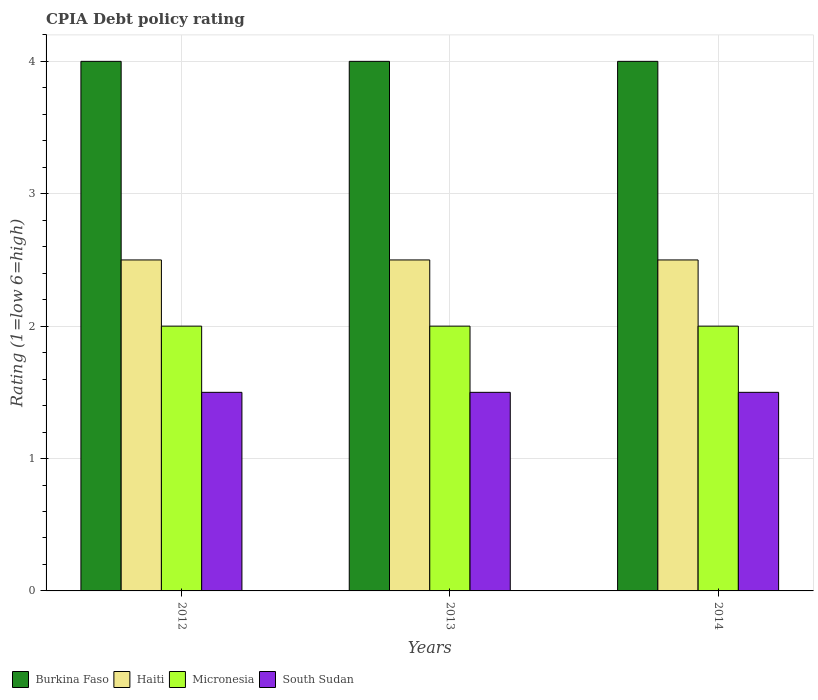How many different coloured bars are there?
Your answer should be compact. 4. How many bars are there on the 3rd tick from the left?
Provide a succinct answer. 4. In how many cases, is the number of bars for a given year not equal to the number of legend labels?
Your answer should be compact. 0. Across all years, what is the maximum CPIA rating in Burkina Faso?
Keep it short and to the point. 4. In how many years, is the CPIA rating in South Sudan greater than 1.4?
Ensure brevity in your answer.  3. Is the CPIA rating in Burkina Faso in 2013 less than that in 2014?
Provide a short and direct response. No. Is the difference between the CPIA rating in Burkina Faso in 2012 and 2014 greater than the difference between the CPIA rating in Micronesia in 2012 and 2014?
Make the answer very short. No. What is the difference between the highest and the lowest CPIA rating in South Sudan?
Offer a very short reply. 0. Is it the case that in every year, the sum of the CPIA rating in South Sudan and CPIA rating in Micronesia is greater than the sum of CPIA rating in Burkina Faso and CPIA rating in Haiti?
Your response must be concise. No. What does the 1st bar from the left in 2014 represents?
Provide a succinct answer. Burkina Faso. What does the 3rd bar from the right in 2012 represents?
Your response must be concise. Haiti. How many years are there in the graph?
Keep it short and to the point. 3. Are the values on the major ticks of Y-axis written in scientific E-notation?
Your answer should be very brief. No. Does the graph contain any zero values?
Make the answer very short. No. Where does the legend appear in the graph?
Give a very brief answer. Bottom left. How many legend labels are there?
Ensure brevity in your answer.  4. What is the title of the graph?
Your answer should be very brief. CPIA Debt policy rating. What is the label or title of the X-axis?
Offer a terse response. Years. What is the Rating (1=low 6=high) of Haiti in 2012?
Provide a succinct answer. 2.5. What is the Rating (1=low 6=high) of South Sudan in 2012?
Give a very brief answer. 1.5. What is the Rating (1=low 6=high) in Burkina Faso in 2013?
Your answer should be very brief. 4. What is the Rating (1=low 6=high) of Haiti in 2013?
Offer a very short reply. 2.5. Across all years, what is the maximum Rating (1=low 6=high) of Haiti?
Ensure brevity in your answer.  2.5. Across all years, what is the maximum Rating (1=low 6=high) in South Sudan?
Your answer should be compact. 1.5. What is the total Rating (1=low 6=high) of Haiti in the graph?
Your answer should be compact. 7.5. What is the total Rating (1=low 6=high) in South Sudan in the graph?
Keep it short and to the point. 4.5. What is the difference between the Rating (1=low 6=high) in Burkina Faso in 2012 and that in 2013?
Your answer should be compact. 0. What is the difference between the Rating (1=low 6=high) of Haiti in 2012 and that in 2013?
Your response must be concise. 0. What is the difference between the Rating (1=low 6=high) in Burkina Faso in 2012 and that in 2014?
Offer a terse response. 0. What is the difference between the Rating (1=low 6=high) in Haiti in 2012 and that in 2014?
Offer a terse response. 0. What is the difference between the Rating (1=low 6=high) of Micronesia in 2012 and that in 2014?
Offer a very short reply. 0. What is the difference between the Rating (1=low 6=high) in South Sudan in 2012 and that in 2014?
Provide a succinct answer. 0. What is the difference between the Rating (1=low 6=high) in Burkina Faso in 2013 and that in 2014?
Your answer should be very brief. 0. What is the difference between the Rating (1=low 6=high) in Burkina Faso in 2012 and the Rating (1=low 6=high) in Micronesia in 2013?
Provide a succinct answer. 2. What is the difference between the Rating (1=low 6=high) of Haiti in 2012 and the Rating (1=low 6=high) of Micronesia in 2013?
Offer a very short reply. 0.5. What is the difference between the Rating (1=low 6=high) of Haiti in 2012 and the Rating (1=low 6=high) of South Sudan in 2013?
Offer a very short reply. 1. What is the difference between the Rating (1=low 6=high) of Micronesia in 2012 and the Rating (1=low 6=high) of South Sudan in 2013?
Make the answer very short. 0.5. What is the difference between the Rating (1=low 6=high) of Burkina Faso in 2012 and the Rating (1=low 6=high) of South Sudan in 2014?
Your answer should be very brief. 2.5. What is the difference between the Rating (1=low 6=high) of Haiti in 2012 and the Rating (1=low 6=high) of South Sudan in 2014?
Make the answer very short. 1. What is the difference between the Rating (1=low 6=high) of Micronesia in 2012 and the Rating (1=low 6=high) of South Sudan in 2014?
Make the answer very short. 0.5. What is the difference between the Rating (1=low 6=high) in Burkina Faso in 2013 and the Rating (1=low 6=high) in Micronesia in 2014?
Provide a short and direct response. 2. What is the difference between the Rating (1=low 6=high) in Burkina Faso in 2013 and the Rating (1=low 6=high) in South Sudan in 2014?
Provide a succinct answer. 2.5. What is the difference between the Rating (1=low 6=high) in Haiti in 2013 and the Rating (1=low 6=high) in Micronesia in 2014?
Give a very brief answer. 0.5. What is the difference between the Rating (1=low 6=high) of Haiti in 2013 and the Rating (1=low 6=high) of South Sudan in 2014?
Offer a terse response. 1. What is the difference between the Rating (1=low 6=high) of Micronesia in 2013 and the Rating (1=low 6=high) of South Sudan in 2014?
Your answer should be very brief. 0.5. What is the average Rating (1=low 6=high) in Burkina Faso per year?
Ensure brevity in your answer.  4. In the year 2012, what is the difference between the Rating (1=low 6=high) in Burkina Faso and Rating (1=low 6=high) in South Sudan?
Your answer should be compact. 2.5. In the year 2012, what is the difference between the Rating (1=low 6=high) in Haiti and Rating (1=low 6=high) in South Sudan?
Provide a succinct answer. 1. In the year 2013, what is the difference between the Rating (1=low 6=high) of Burkina Faso and Rating (1=low 6=high) of Micronesia?
Provide a short and direct response. 2. In the year 2013, what is the difference between the Rating (1=low 6=high) in Haiti and Rating (1=low 6=high) in South Sudan?
Provide a succinct answer. 1. In the year 2013, what is the difference between the Rating (1=low 6=high) in Micronesia and Rating (1=low 6=high) in South Sudan?
Ensure brevity in your answer.  0.5. In the year 2014, what is the difference between the Rating (1=low 6=high) in Burkina Faso and Rating (1=low 6=high) in Haiti?
Provide a short and direct response. 1.5. In the year 2014, what is the difference between the Rating (1=low 6=high) of Burkina Faso and Rating (1=low 6=high) of Micronesia?
Offer a very short reply. 2. In the year 2014, what is the difference between the Rating (1=low 6=high) of Haiti and Rating (1=low 6=high) of South Sudan?
Your answer should be compact. 1. What is the ratio of the Rating (1=low 6=high) in Burkina Faso in 2012 to that in 2013?
Your answer should be very brief. 1. What is the ratio of the Rating (1=low 6=high) in Micronesia in 2012 to that in 2013?
Provide a short and direct response. 1. What is the ratio of the Rating (1=low 6=high) of South Sudan in 2012 to that in 2014?
Keep it short and to the point. 1. What is the ratio of the Rating (1=low 6=high) in Haiti in 2013 to that in 2014?
Offer a very short reply. 1. What is the ratio of the Rating (1=low 6=high) in Micronesia in 2013 to that in 2014?
Offer a very short reply. 1. What is the difference between the highest and the second highest Rating (1=low 6=high) of South Sudan?
Offer a terse response. 0. What is the difference between the highest and the lowest Rating (1=low 6=high) in Haiti?
Offer a very short reply. 0. What is the difference between the highest and the lowest Rating (1=low 6=high) in Micronesia?
Provide a short and direct response. 0. What is the difference between the highest and the lowest Rating (1=low 6=high) in South Sudan?
Make the answer very short. 0. 